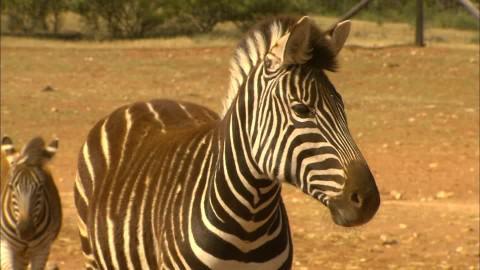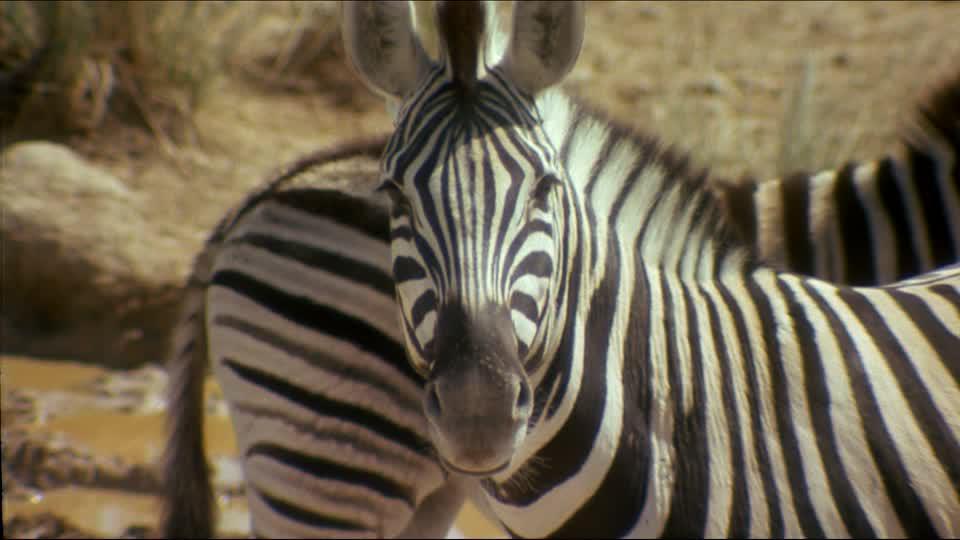The first image is the image on the left, the second image is the image on the right. Considering the images on both sides, is "There are two zebras and blue sky visible in the left image." valid? Answer yes or no. No. 